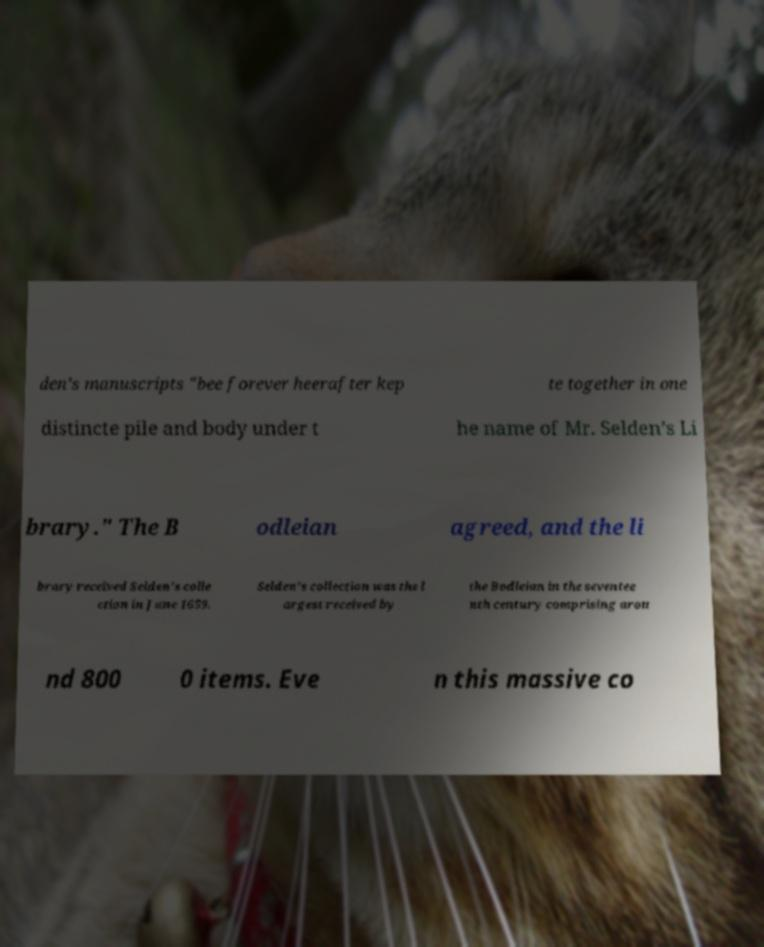I need the written content from this picture converted into text. Can you do that? den’s manuscripts "bee forever heerafter kep te together in one distincte pile and body under t he name of Mr. Selden’s Li brary." The B odleian agreed, and the li brary received Selden’s colle ction in June 1659. Selden’s collection was the l argest received by the Bodleian in the seventee nth century comprising arou nd 800 0 items. Eve n this massive co 